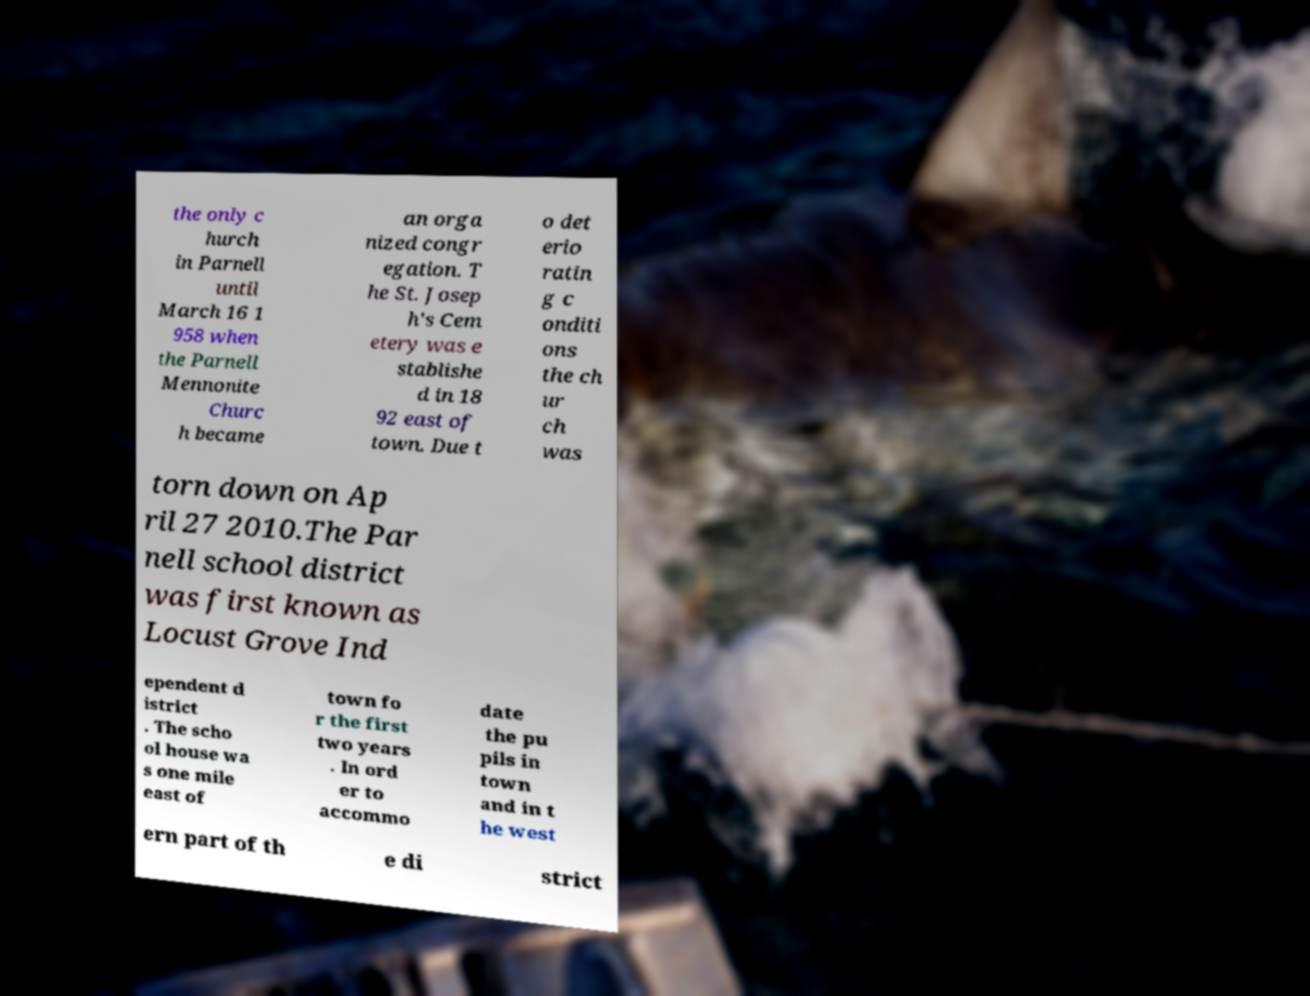Could you extract and type out the text from this image? the only c hurch in Parnell until March 16 1 958 when the Parnell Mennonite Churc h became an orga nized congr egation. T he St. Josep h's Cem etery was e stablishe d in 18 92 east of town. Due t o det erio ratin g c onditi ons the ch ur ch was torn down on Ap ril 27 2010.The Par nell school district was first known as Locust Grove Ind ependent d istrict . The scho ol house wa s one mile east of town fo r the first two years . In ord er to accommo date the pu pils in town and in t he west ern part of th e di strict 